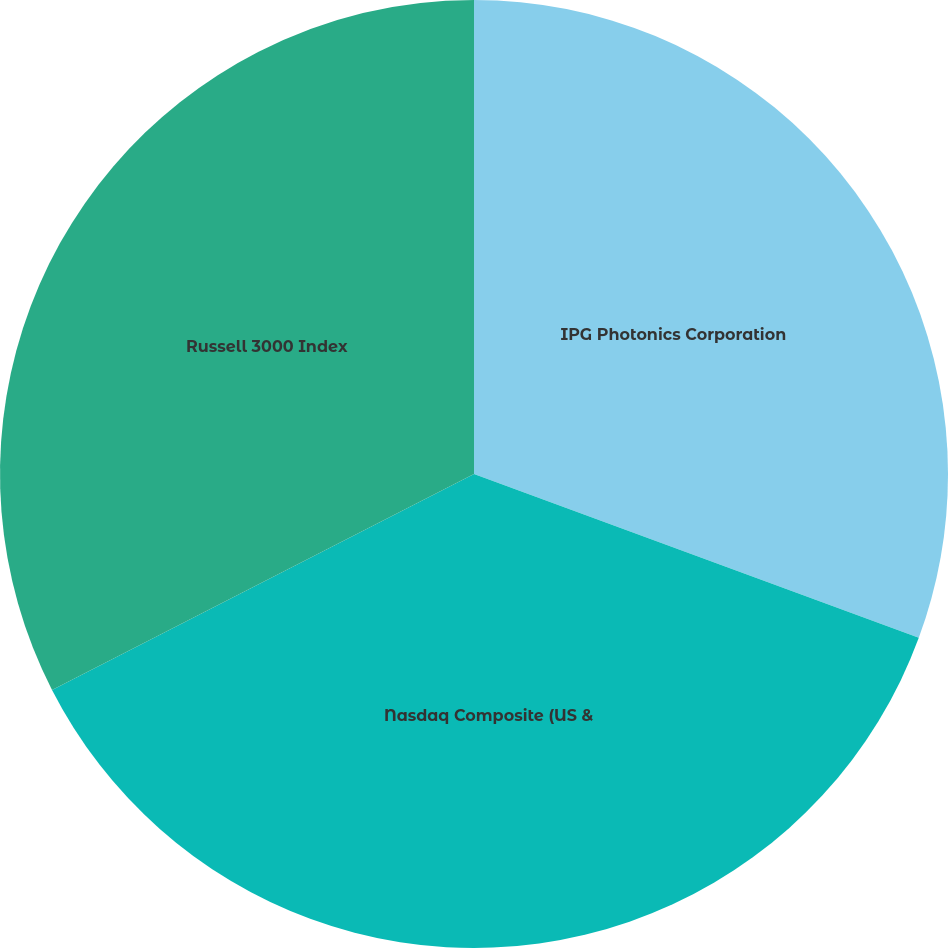<chart> <loc_0><loc_0><loc_500><loc_500><pie_chart><fcel>IPG Photonics Corporation<fcel>Nasdaq Composite (US &<fcel>Russell 3000 Index<nl><fcel>30.62%<fcel>36.86%<fcel>32.53%<nl></chart> 